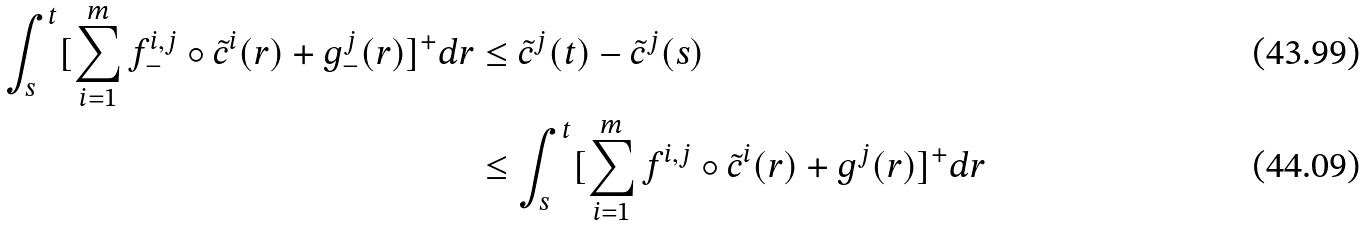Convert formula to latex. <formula><loc_0><loc_0><loc_500><loc_500>\int _ { s } ^ { t } [ \sum _ { i = 1 } ^ { m } f ^ { i , j } _ { - } \circ \tilde { c } ^ { i } ( r ) + g ^ { j } _ { - } ( r ) ] ^ { + } d r & \leq \tilde { c } ^ { j } ( t ) - \tilde { c } ^ { j } ( s ) \\ & \leq \int _ { s } ^ { t } [ \sum _ { i = 1 } ^ { m } f ^ { i , j } \circ \tilde { c } ^ { i } ( r ) + g ^ { j } ( r ) ] ^ { + } d r</formula> 